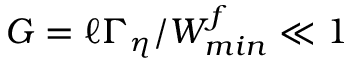Convert formula to latex. <formula><loc_0><loc_0><loc_500><loc_500>G = \ell \Gamma _ { \eta } / W _ { \min } ^ { f } \ll 1</formula> 